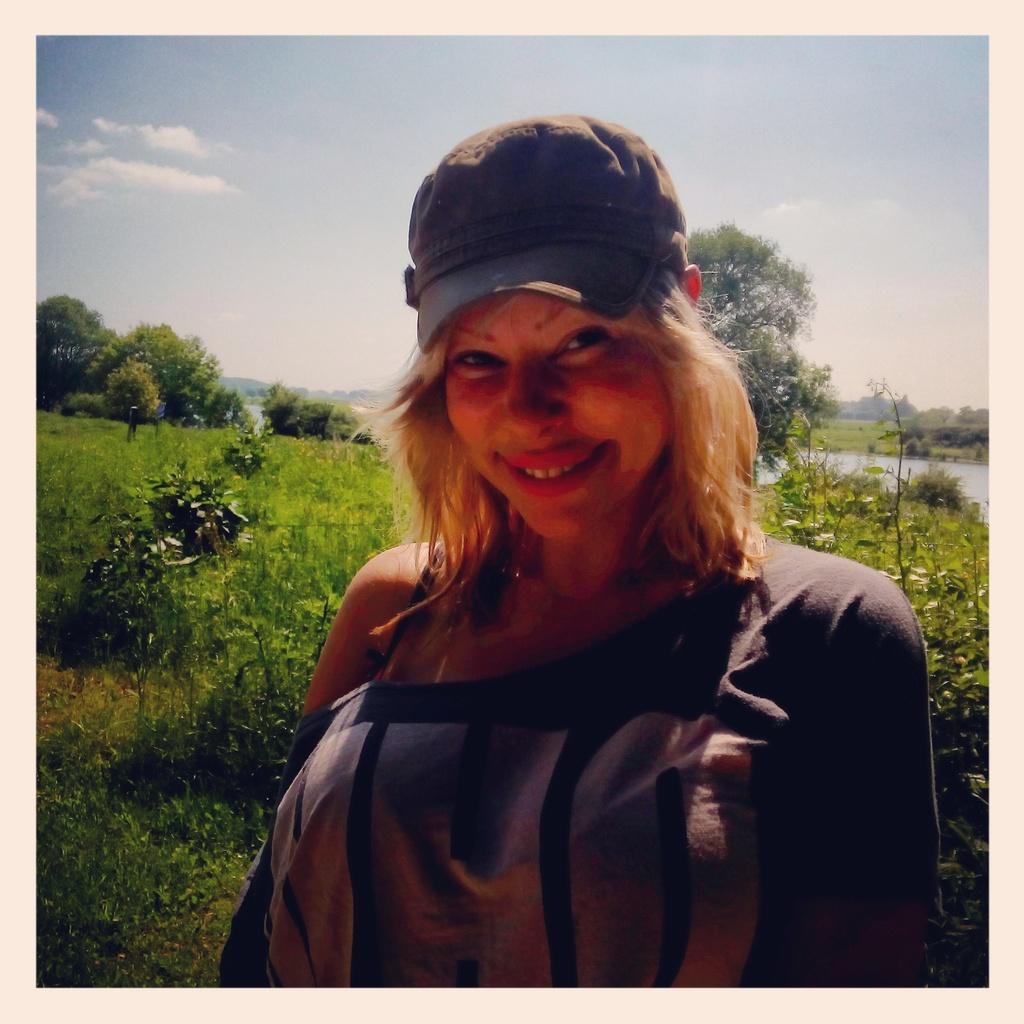Describe this image in one or two sentences. In this picture we can see a woman, behind we can see plants, grass, trees and we can see the lake. 